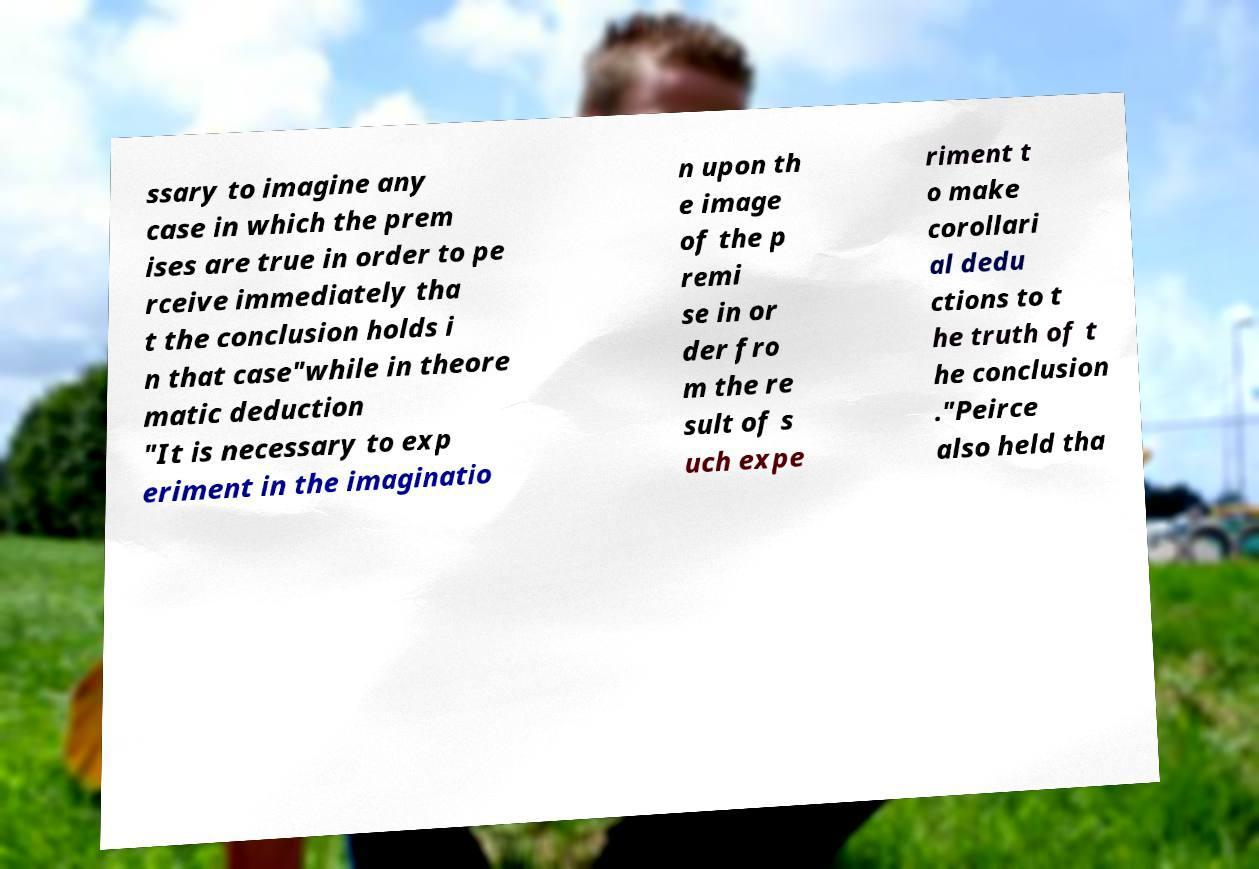Could you extract and type out the text from this image? ssary to imagine any case in which the prem ises are true in order to pe rceive immediately tha t the conclusion holds i n that case"while in theore matic deduction "It is necessary to exp eriment in the imaginatio n upon th e image of the p remi se in or der fro m the re sult of s uch expe riment t o make corollari al dedu ctions to t he truth of t he conclusion ."Peirce also held tha 